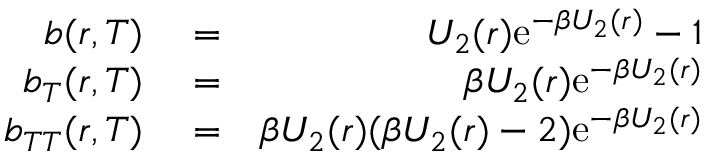<formula> <loc_0><loc_0><loc_500><loc_500>\begin{array} { r l r } { b ( r , T ) } & = } & { U _ { 2 } ( r ) e ^ { - \beta U _ { 2 } ( r ) } - 1 } \\ { b _ { T } ( r , T ) } & = } & { \beta U _ { 2 } ( r ) e ^ { - \beta U _ { 2 } ( r ) } } \\ { b _ { T T } ( r , T ) } & = } & { \beta U _ { 2 } ( r ) ( \beta U _ { 2 } ( r ) - 2 ) e ^ { - \beta U _ { 2 } ( r ) } } \end{array}</formula> 